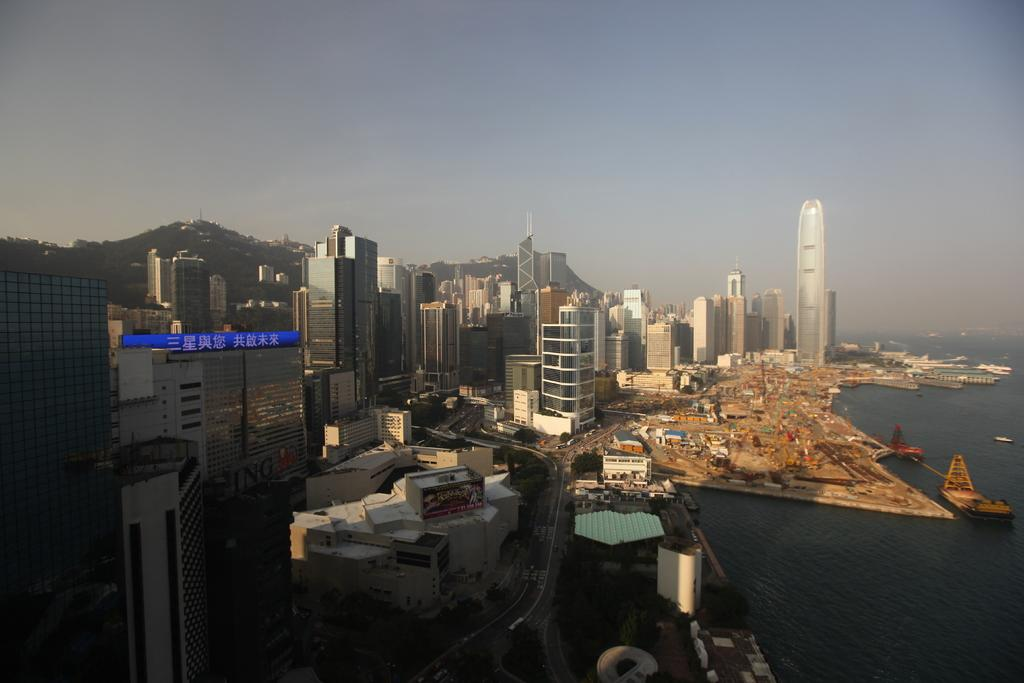What type of structures can be seen in the image? There are buildings in the image. What body of water is present in the image? There is a harbor in the image. What type of vehicles are in the image? There are ships in the image. What natural feature is visible in the image? There are hills in the image. What type of pathway is present in the image? There is a road in the image. What else can be seen moving in the image? There are vehicles in the image. What part of the natural environment is visible in the image? There is sky visible in the image. What is present in the sky in the image? There are clouds in the image. What type of oven can be seen in the image? There is no oven present in the image. What type of harmony is being played by the vehicles in the image? The vehicles in the image are not playing any music or harmony; they are simply moving along the road. 